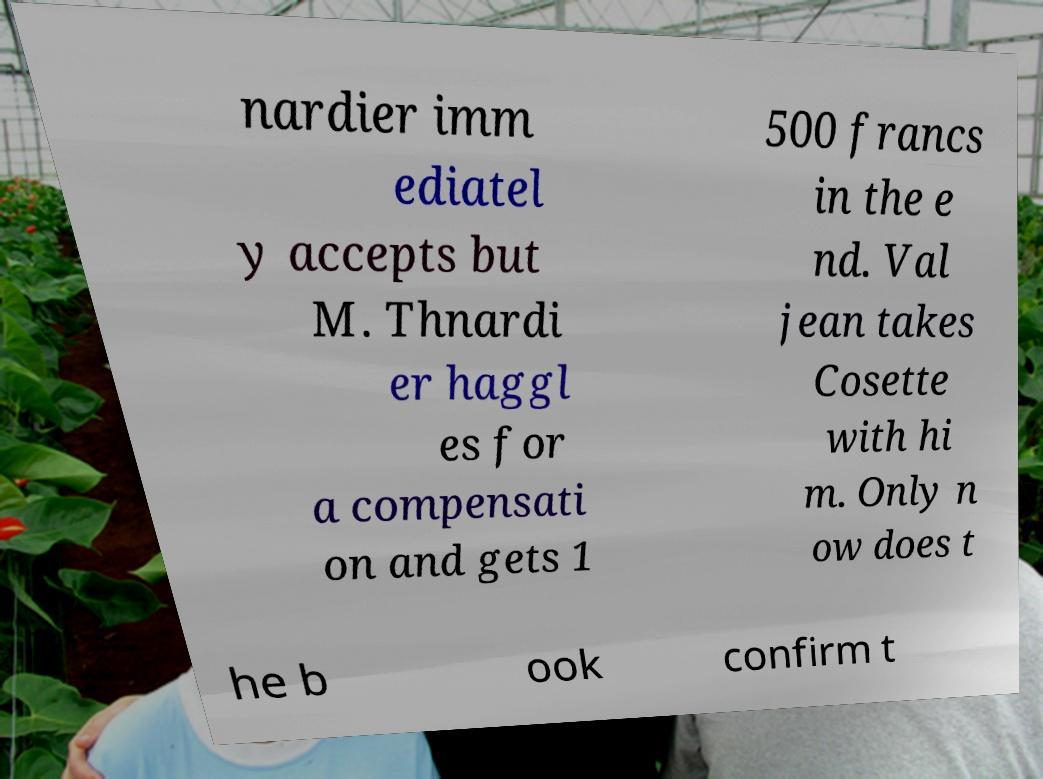Please read and relay the text visible in this image. What does it say? nardier imm ediatel y accepts but M. Thnardi er haggl es for a compensati on and gets 1 500 francs in the e nd. Val jean takes Cosette with hi m. Only n ow does t he b ook confirm t 